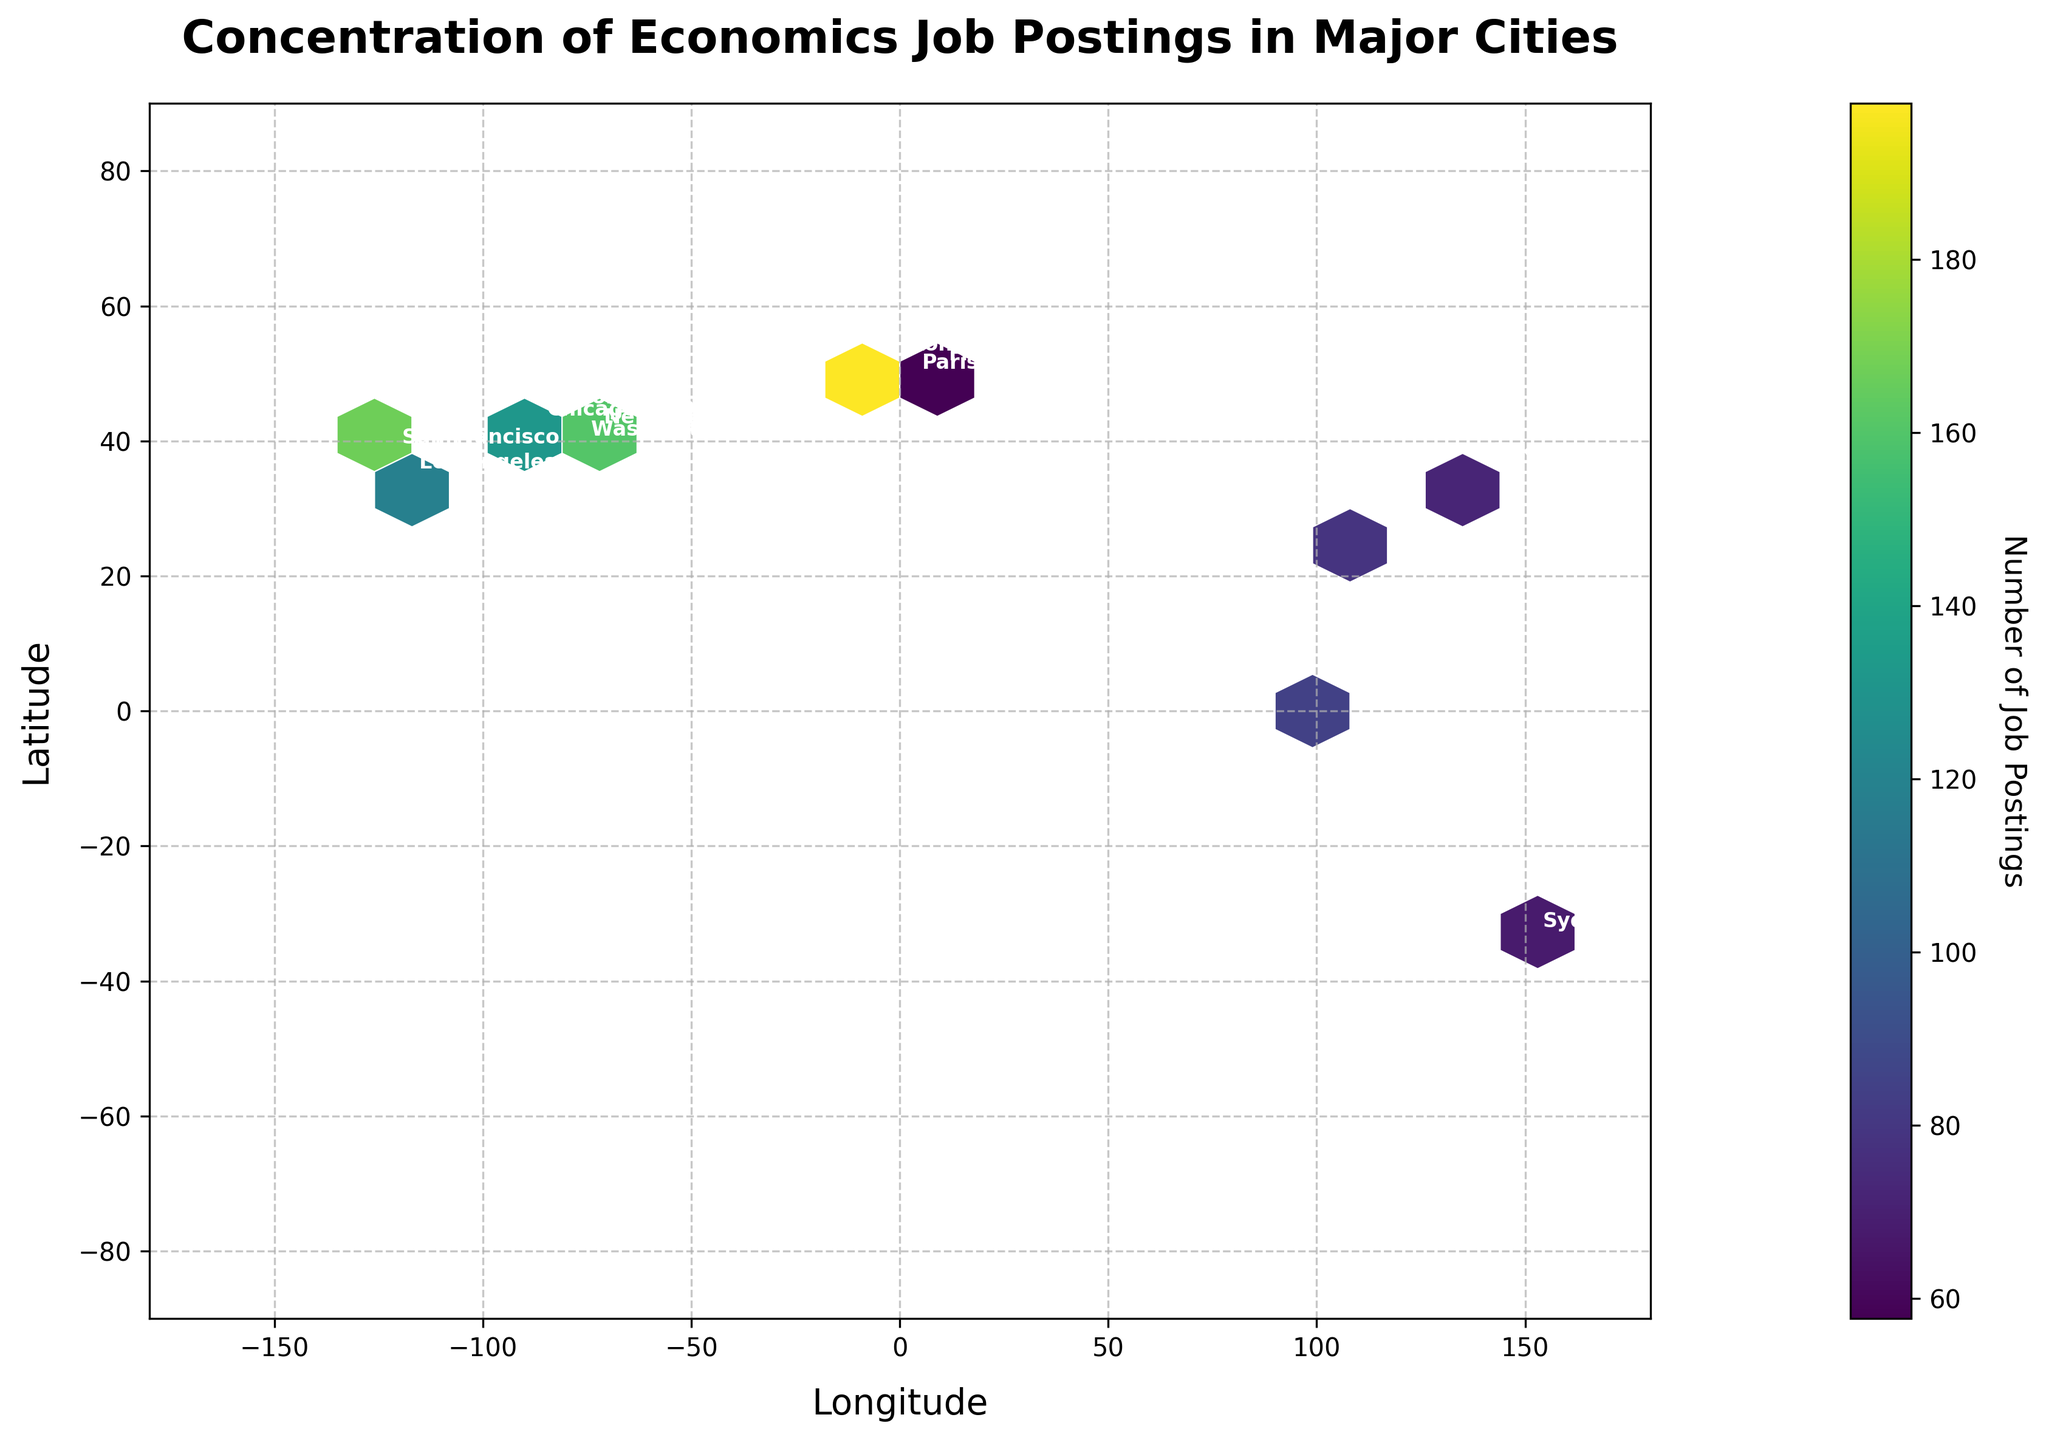What is the title of the figure? The title of the plot can be found at the top of the figure.
Answer: Concentration of Economics Job Postings in Major Cities How many job postings are there in New York City? Locate New York City on the plot and observe the annotated figure next to its coordinates.
Answer: 245 Which city has the highest concentration of job postings? The color intensity on the hexbin plot and the annotations identify the city with the highest postings. Look for the darkest cell and verify with annotation.
Answer: New York City What are the units marked on the x-axis? The x-axis represents longitude, typically ranging from -180 to 180 degrees.
Answer: Longitude (degrees) Which region (longitude and latitude range) has the densest job postings in the plot? Observe the areas with the darkest hexagon along both the x (longitude) and y (latitude) axes.
Answer: Around -74 longitude and 40.7 latitude (New York City area) How many cities are represented in the figure? Count the number of unique annotations representing different cities on the plot.
Answer: 15 Is there a significant concentration of job postings in the Southern Hemisphere? Look at the color intensity and number of annotated points below 0 degrees latitude.
Answer: No Which cities have a similar number of job postings and are located close to each other by longitude? Identify cities with similar hues in the same longitudinal region, cross-referencing their annotations.
Answer: Boston and Washington D.C Is there a higher concentration of job postings in Europe or Asia? Compare the color densities and annotations for cities located in Europe's and Asia's longitude and latitude ranges.
Answer: Europe What is the color of the legend representing approximately 245 job postings? Find the color scale in the legend that corresponds to the number near 245.
Answer: Dark purple 